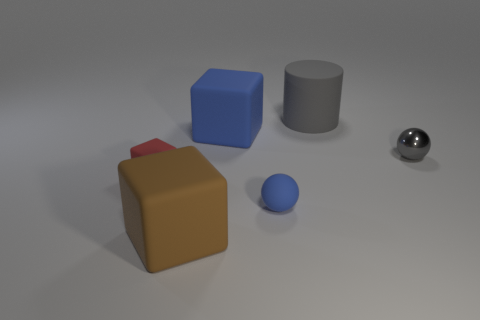There is a big thing that is the same color as the metal sphere; what is its shape?
Keep it short and to the point. Cylinder. How many cylinders are gray metallic things or gray things?
Your response must be concise. 1. Are the ball that is in front of the small red block and the tiny gray sphere made of the same material?
Provide a succinct answer. No. How many other things are there of the same size as the red object?
Your response must be concise. 2. What number of small things are brown rubber things or brown rubber balls?
Your answer should be compact. 0. Is the metal thing the same color as the big cylinder?
Your response must be concise. Yes. Are there more gray objects that are behind the big cylinder than tiny blocks that are in front of the big blue rubber object?
Your response must be concise. No. There is a ball that is on the right side of the tiny blue thing; does it have the same color as the small cube?
Ensure brevity in your answer.  No. Is there anything else of the same color as the rubber sphere?
Provide a short and direct response. Yes. Are there more rubber cylinders that are in front of the large gray object than small blue matte cubes?
Your answer should be very brief. No. 